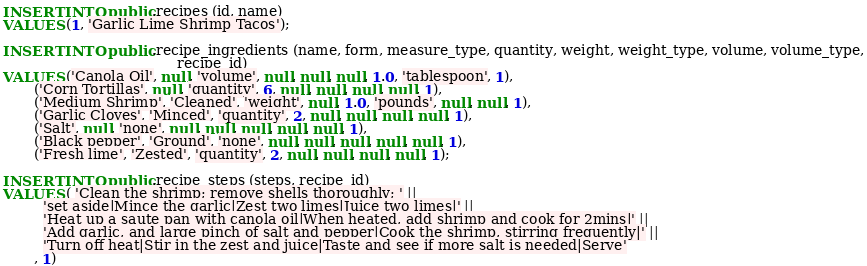<code> <loc_0><loc_0><loc_500><loc_500><_SQL_>INSERT INTO public.recipes (id, name)
VALUES (1, 'Garlic Lime Shrimp Tacos');

INSERT INTO public.recipe_ingredients (name, form, measure_type, quantity, weight, weight_type, volume, volume_type,
                                       recipe_id)
VALUES ('Canola Oil', null, 'volume', null, null, null, 1.0, 'tablespoon', 1),
       ('Corn Tortillas', null, 'quantity', 6, null, null, null, null, 1),
       ('Medium Shrimp', 'Cleaned', 'weight', null, 1.0, 'pounds', null, null, 1),
       ('Garlic Cloves', 'Minced', 'quantity', 2, null, null, null, null, 1),
       ('Salt', null, 'none', null, null, null, null, null, 1),
       ('Black pepper', 'Ground', 'none', null, null, null, null, null, 1),
       ('Fresh lime', 'Zested', 'quantity', 2, null, null, null, null, 1);

INSERT INTO public.recipe_steps (steps, recipe_id)
VALUES ( 'Clean the shrimp; remove shells thoroughly; ' ||
         'set aside|Mince the garlic|Zest two limes|Juice two limes|' ||
         'Heat up a saute pan with canola oil|When heated, add shrimp and cook for 2mins|' ||
         'Add garlic, and large pinch of salt and pepper|Cook the shrimp, stirring frequently|' ||
         'Turn off heat|Stir in the zest and juice|Taste and see if more salt is needed|Serve'
       , 1)
</code> 